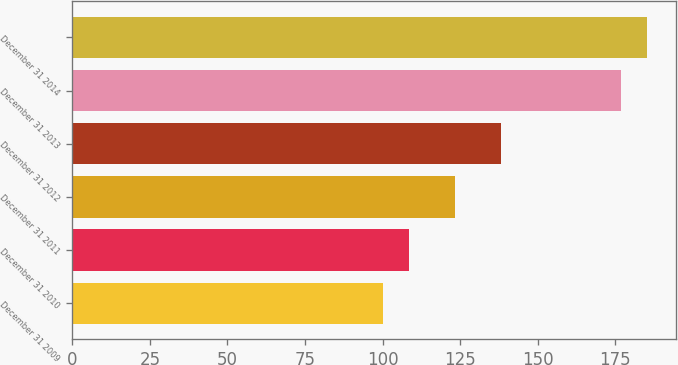Convert chart. <chart><loc_0><loc_0><loc_500><loc_500><bar_chart><fcel>December 31 2009<fcel>December 31 2010<fcel>December 31 2011<fcel>December 31 2012<fcel>December 31 2013<fcel>December 31 2014<nl><fcel>100<fcel>108.4<fcel>123.3<fcel>138.3<fcel>176.9<fcel>185.3<nl></chart> 